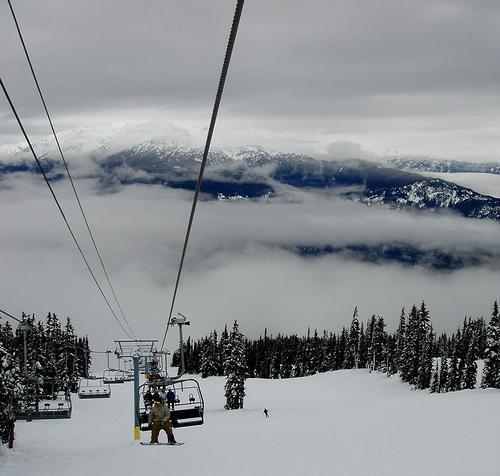How many people are on the front chair of the ski lift?
Give a very brief answer. 1. How many people are skiing down the mountain?
Give a very brief answer. 1. 